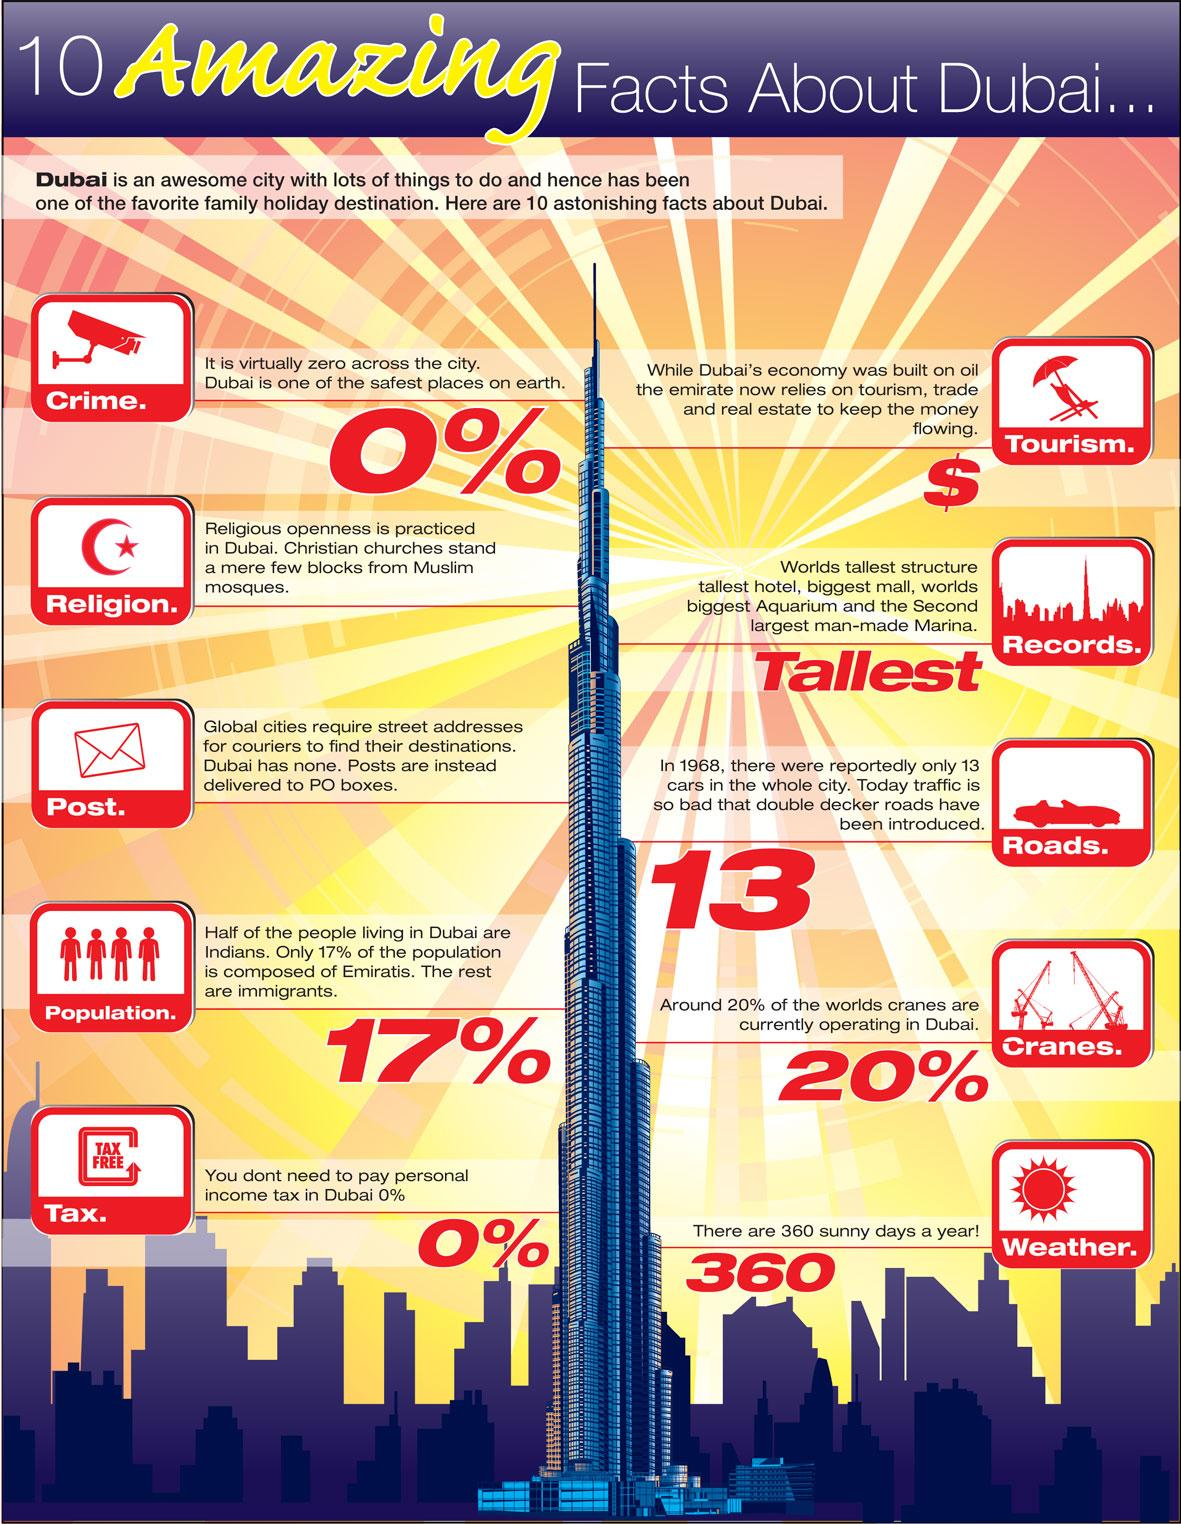Mention a couple of crucial points in this snapshot. Dubai is home to the world's largest aquarium. In Dubai, 0% represents a crime-free environment, zero personal income tax, and a thriving economy. 